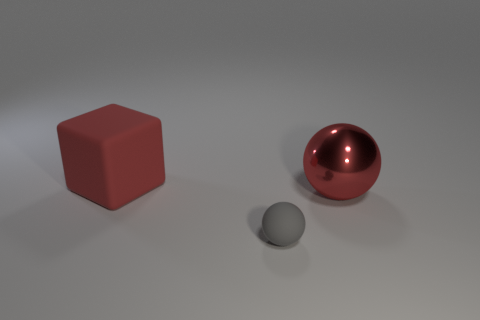Add 3 large red spheres. How many objects exist? 6 Subtract all cubes. How many objects are left? 2 Subtract all tiny gray balls. Subtract all gray matte spheres. How many objects are left? 1 Add 3 large red metallic spheres. How many large red metallic spheres are left? 4 Add 1 objects. How many objects exist? 4 Subtract 0 cyan blocks. How many objects are left? 3 